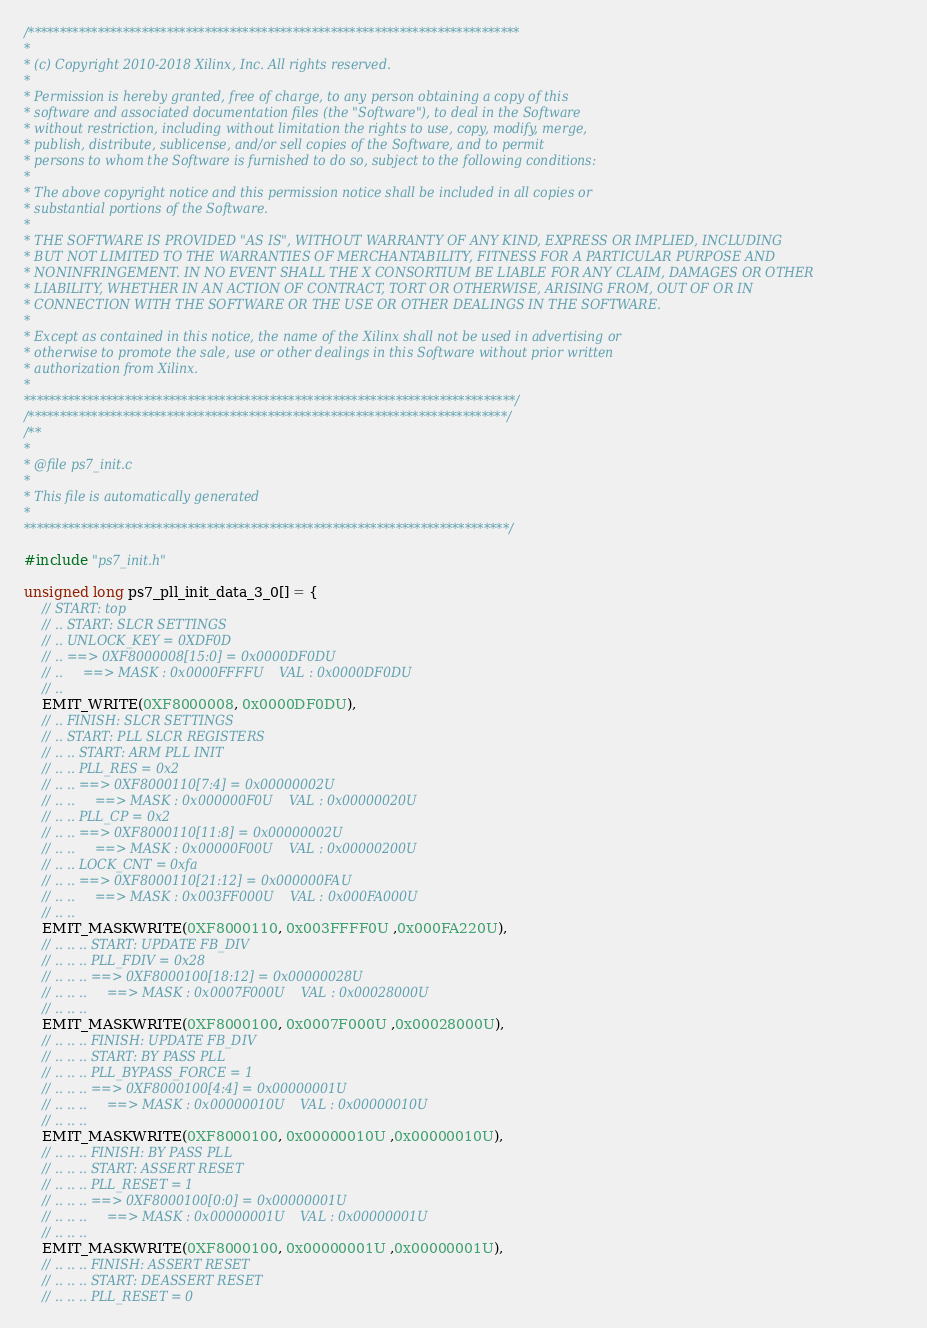<code> <loc_0><loc_0><loc_500><loc_500><_C_>/******************************************************************************
*
* (c) Copyright 2010-2018 Xilinx, Inc. All rights reserved.
*
* Permission is hereby granted, free of charge, to any person obtaining a copy of this
* software and associated documentation files (the "Software"), to deal in the Software
* without restriction, including without limitation the rights to use, copy, modify, merge,
* publish, distribute, sublicense, and/or sell copies of the Software, and to permit
* persons to whom the Software is furnished to do so, subject to the following conditions:
*
* The above copyright notice and this permission notice shall be included in all copies or
* substantial portions of the Software.
*
* THE SOFTWARE IS PROVIDED "AS IS", WITHOUT WARRANTY OF ANY KIND, EXPRESS OR IMPLIED, INCLUDING
* BUT NOT LIMITED TO THE WARRANTIES OF MERCHANTABILITY, FITNESS FOR A PARTICULAR PURPOSE AND
* NONINFRINGEMENT. IN NO EVENT SHALL THE X CONSORTIUM BE LIABLE FOR ANY CLAIM, DAMAGES OR OTHER
* LIABILITY, WHETHER IN AN ACTION OF CONTRACT, TORT OR OTHERWISE, ARISING FROM, OUT OF OR IN
* CONNECTION WITH THE SOFTWARE OR THE USE OR OTHER DEALINGS IN THE SOFTWARE.
*
* Except as contained in this notice, the name of the Xilinx shall not be used in advertising or
* otherwise to promote the sale, use or other dealings in this Software without prior written
* authorization from Xilinx.
*
******************************************************************************/
/****************************************************************************/
/**
*
* @file ps7_init.c
*
* This file is automatically generated 
*
*****************************************************************************/

#include "ps7_init.h"

unsigned long ps7_pll_init_data_3_0[] = {
    // START: top
    // .. START: SLCR SETTINGS
    // .. UNLOCK_KEY = 0XDF0D
    // .. ==> 0XF8000008[15:0] = 0x0000DF0DU
    // ..     ==> MASK : 0x0000FFFFU    VAL : 0x0000DF0DU
    // .. 
    EMIT_WRITE(0XF8000008, 0x0000DF0DU),
    // .. FINISH: SLCR SETTINGS
    // .. START: PLL SLCR REGISTERS
    // .. .. START: ARM PLL INIT
    // .. .. PLL_RES = 0x2
    // .. .. ==> 0XF8000110[7:4] = 0x00000002U
    // .. ..     ==> MASK : 0x000000F0U    VAL : 0x00000020U
    // .. .. PLL_CP = 0x2
    // .. .. ==> 0XF8000110[11:8] = 0x00000002U
    // .. ..     ==> MASK : 0x00000F00U    VAL : 0x00000200U
    // .. .. LOCK_CNT = 0xfa
    // .. .. ==> 0XF8000110[21:12] = 0x000000FAU
    // .. ..     ==> MASK : 0x003FF000U    VAL : 0x000FA000U
    // .. .. 
    EMIT_MASKWRITE(0XF8000110, 0x003FFFF0U ,0x000FA220U),
    // .. .. .. START: UPDATE FB_DIV
    // .. .. .. PLL_FDIV = 0x28
    // .. .. .. ==> 0XF8000100[18:12] = 0x00000028U
    // .. .. ..     ==> MASK : 0x0007F000U    VAL : 0x00028000U
    // .. .. .. 
    EMIT_MASKWRITE(0XF8000100, 0x0007F000U ,0x00028000U),
    // .. .. .. FINISH: UPDATE FB_DIV
    // .. .. .. START: BY PASS PLL
    // .. .. .. PLL_BYPASS_FORCE = 1
    // .. .. .. ==> 0XF8000100[4:4] = 0x00000001U
    // .. .. ..     ==> MASK : 0x00000010U    VAL : 0x00000010U
    // .. .. .. 
    EMIT_MASKWRITE(0XF8000100, 0x00000010U ,0x00000010U),
    // .. .. .. FINISH: BY PASS PLL
    // .. .. .. START: ASSERT RESET
    // .. .. .. PLL_RESET = 1
    // .. .. .. ==> 0XF8000100[0:0] = 0x00000001U
    // .. .. ..     ==> MASK : 0x00000001U    VAL : 0x00000001U
    // .. .. .. 
    EMIT_MASKWRITE(0XF8000100, 0x00000001U ,0x00000001U),
    // .. .. .. FINISH: ASSERT RESET
    // .. .. .. START: DEASSERT RESET
    // .. .. .. PLL_RESET = 0</code> 